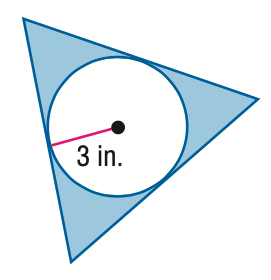Question: Find the area of the shaded region. Assume that all polygons that appear to be regular are regular. Round to the nearest tenth.
Choices:
A. 18.5
B. 46.8
C. 52.7
D. 65.3
Answer with the letter. Answer: A 